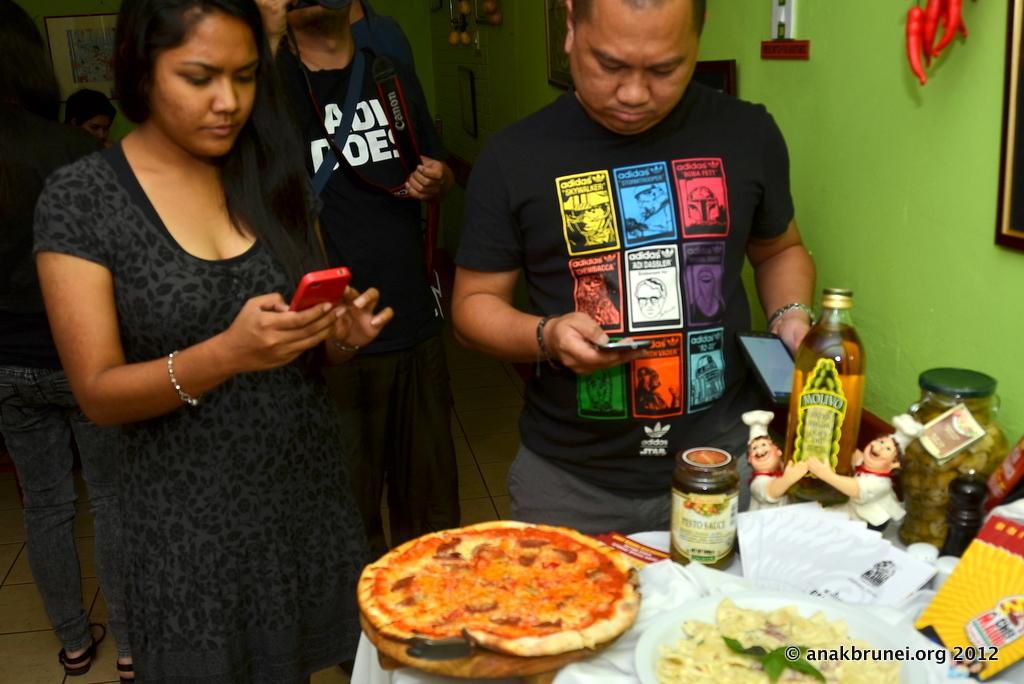Describe this image in one or two sentences. In this image there are people standing and holding mobiles. At the bottom there is a table and we can see bottles, jar, napkins, plate, pizza, tray, dolls and some food placed on the table. In the background there is a wall and we can see decors and frames placed on the wall. 